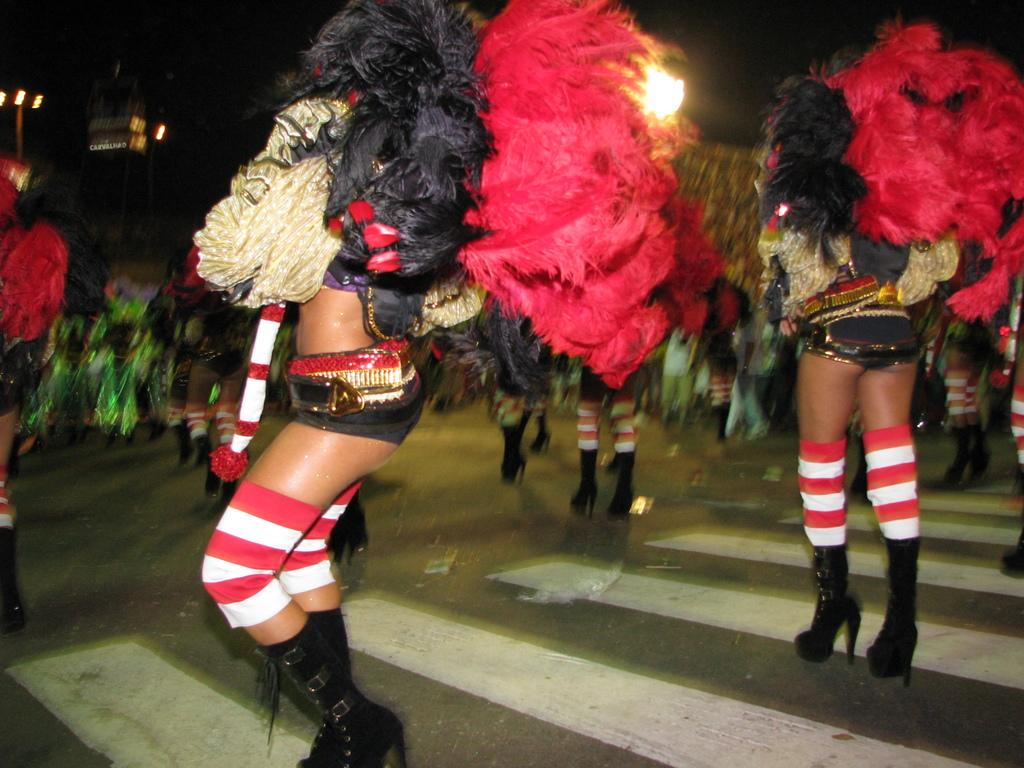Who is present in the image? There are ladies in the image. What are the ladies wearing? The ladies are dressed in costumes. What is at the bottom of the image? There is a road at the bottom of the image. What can be seen in the background of the image? There are poles and lights in the background of the image. What type of weather can be seen in the image? The image does not show any weather conditions; it only depicts the ladies, their costumes, the road, and the background elements. How many horses are present in the image? There are no horses present in the image. 